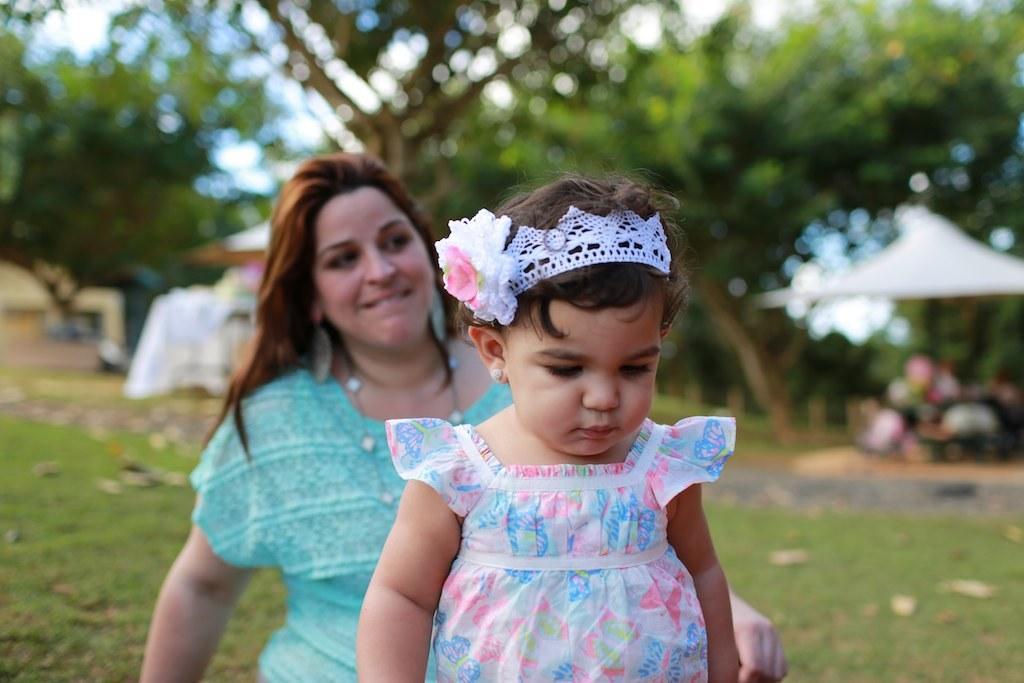In one or two sentences, can you explain what this image depicts? In this image there is grass at the bottom. There are people in the foreground. There are trees in the background. And there is sky at the top. 